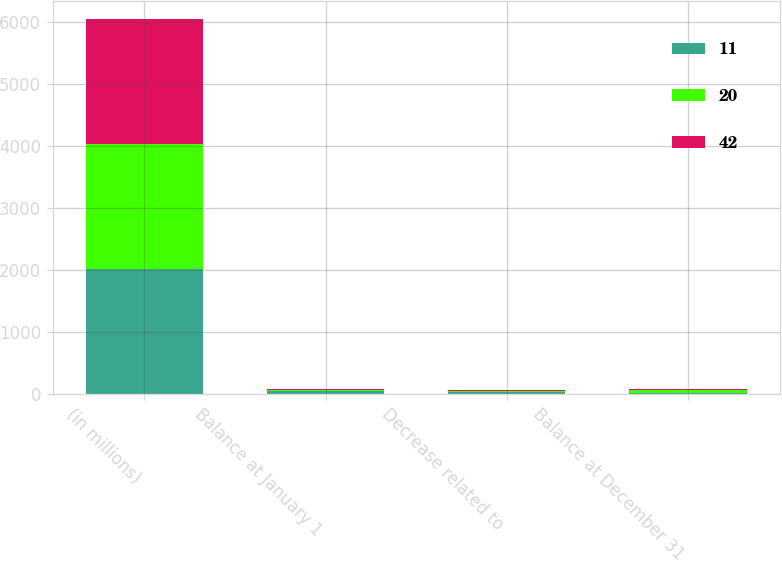Convert chart. <chart><loc_0><loc_0><loc_500><loc_500><stacked_bar_chart><ecel><fcel>(in millions)<fcel>Balance at January 1<fcel>Decrease related to<fcel>Balance at December 31<nl><fcel>11<fcel>2013<fcel>42<fcel>31<fcel>11<nl><fcel>20<fcel>2012<fcel>20<fcel>11<fcel>42<nl><fcel>42<fcel>2011<fcel>10<fcel>12<fcel>20<nl></chart> 